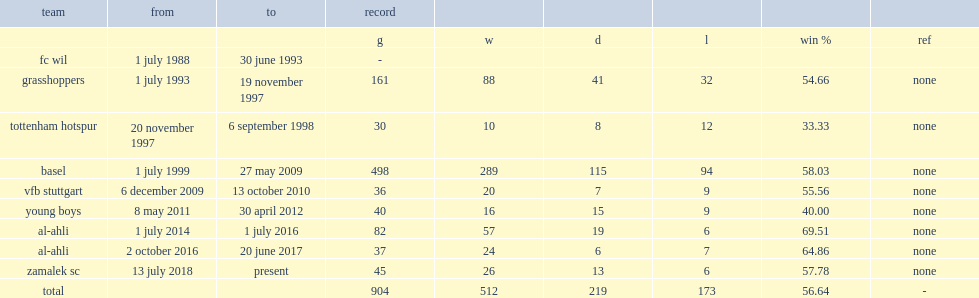When did christian gross become the manager of basel? 1 july 1999. 